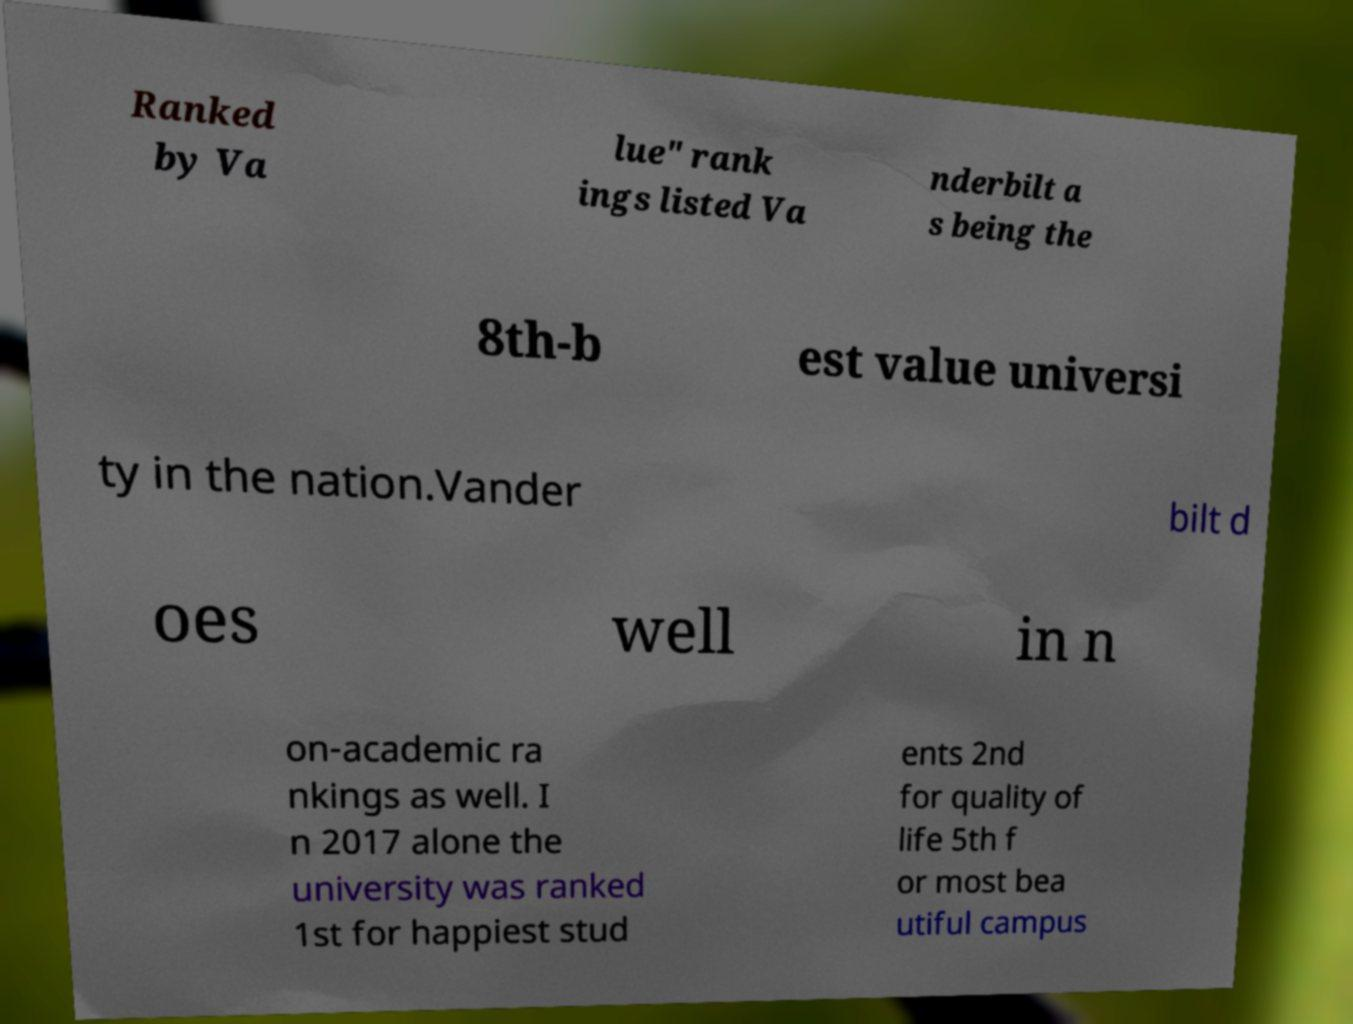I need the written content from this picture converted into text. Can you do that? Ranked by Va lue" rank ings listed Va nderbilt a s being the 8th-b est value universi ty in the nation.Vander bilt d oes well in n on-academic ra nkings as well. I n 2017 alone the university was ranked 1st for happiest stud ents 2nd for quality of life 5th f or most bea utiful campus 